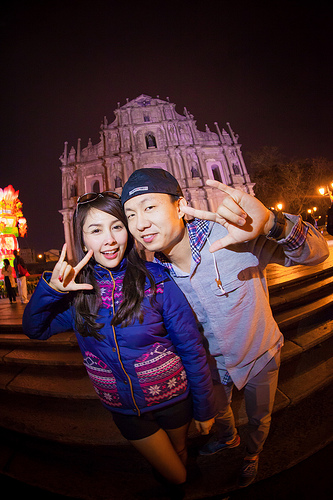<image>
Is there a hat on the woman? No. The hat is not positioned on the woman. They may be near each other, but the hat is not supported by or resting on top of the woman. 